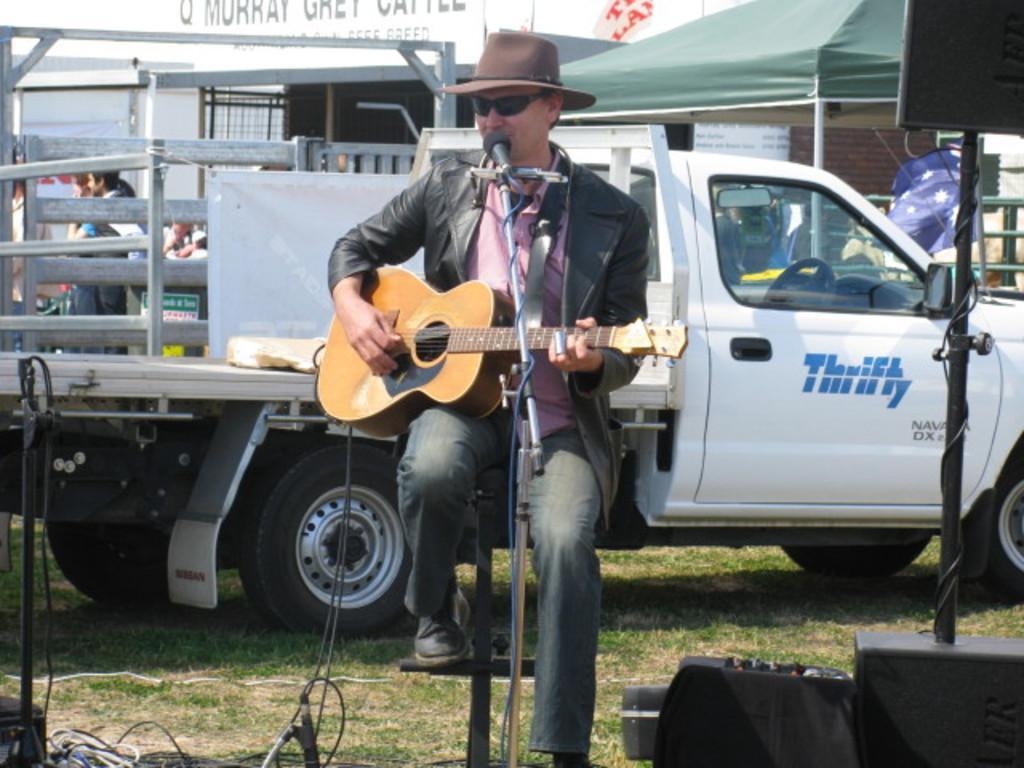Could you give a brief overview of what you see in this image? In this image i can see a person sitting and holding a guitar, there is a microphone in front of him. In the background i can see few vehicles and few people standing. 